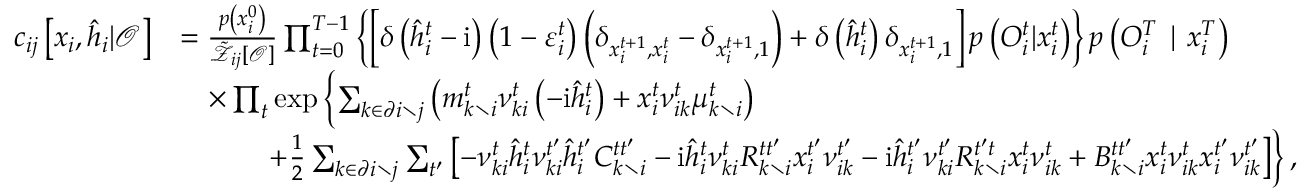Convert formula to latex. <formula><loc_0><loc_0><loc_500><loc_500>\begin{array} { r l } { c _ { i j } \left [ x _ { i } , \hat { h } _ { i } | \mathcal { O } \right ] } & { = \frac { p \left ( x _ { i } ^ { 0 } \right ) } { \tilde { \mathcal { Z } } _ { i j } [ \mathcal { O } ] } \prod _ { t = 0 } ^ { T - 1 } \left \{ \left [ \delta \left ( \hat { h } _ { i } ^ { t } - i \right ) \left ( 1 - \varepsilon _ { i } ^ { t } \right ) \left ( \delta _ { x _ { i } ^ { t + 1 } , x _ { i } ^ { t } } - \delta _ { x _ { i } ^ { t + 1 } , 1 } \right ) + \delta \left ( \hat { h } _ { i } ^ { t } \right ) \delta _ { x _ { i } ^ { t + 1 } , 1 } \right ] p \left ( { O } _ { i } ^ { t } | x _ { i } ^ { t } \right ) \right \} p \left ( { O } _ { i } ^ { T } | x _ { i } ^ { T } \right ) } \\ & { \quad \times \prod _ { t } \exp \left \{ \sum _ { k \in \partial i \ j } \left ( m _ { k \ i } ^ { t } \nu _ { k i } ^ { t } \left ( - i \hat { h } _ { i } ^ { t } \right ) + x _ { i } ^ { t } \nu _ { i k } ^ { t } \mu _ { k \ i } ^ { t } \right ) } \\ & { \quad + \frac { 1 } { 2 } \sum _ { k \in \partial i \ j } \sum _ { t ^ { \prime } } \left [ - \nu _ { k i } ^ { t } \hat { h } _ { i } ^ { t } \nu _ { k i } ^ { t ^ { \prime } } \hat { h } _ { i } ^ { t ^ { \prime } } C _ { k \ i } ^ { t t ^ { \prime } } - i \hat { h } _ { i } ^ { t } \nu _ { k i } ^ { t } R _ { k \ i } ^ { t t ^ { \prime } } x _ { i } ^ { t ^ { \prime } } \nu _ { i k } ^ { t ^ { \prime } } - i \hat { h } _ { i } ^ { t ^ { \prime } } \nu _ { k i } ^ { t ^ { \prime } } R _ { k \ i } ^ { t ^ { \prime } t } x _ { i } ^ { t } \nu _ { i k } ^ { t } + B _ { k \ i } ^ { t t ^ { \prime } } x _ { i } ^ { t } \nu _ { i k } ^ { t } x _ { i } ^ { t ^ { \prime } } \nu _ { i k } ^ { t ^ { \prime } } \right ] \right \} , } \end{array}</formula> 